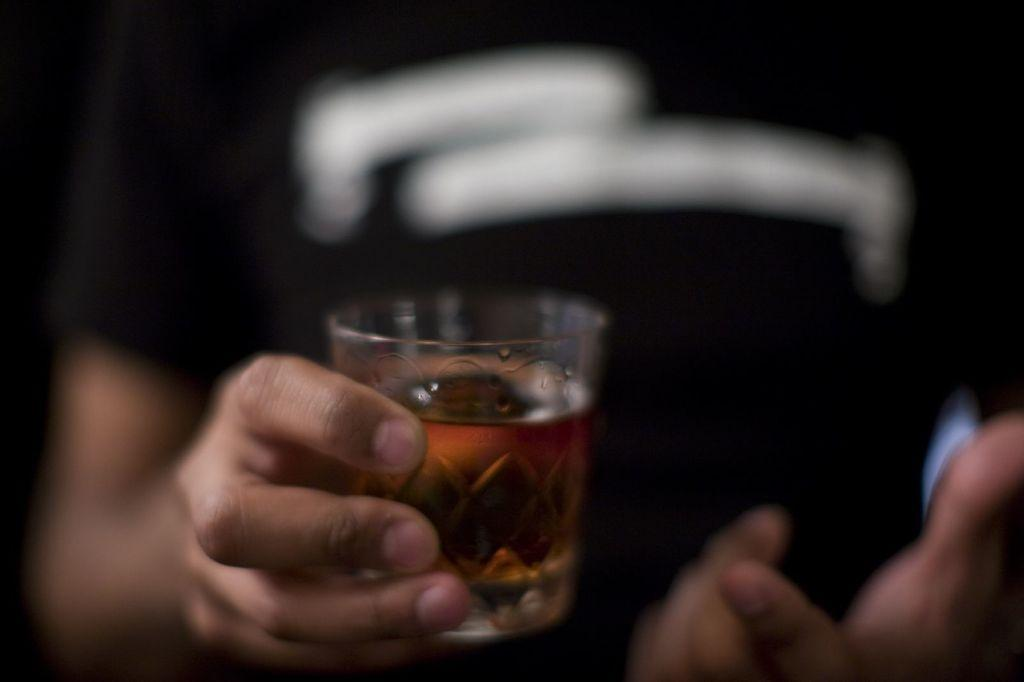Who or what is present in the image? There is a person in the image. What is the person holding in the image? The person is holding a glass in the image. What is inside the glass that the person is holding? The glass contains a drink. What type of egg can be seen in the image? There is no egg present in the image. Is the person in the image being attacked by someone or something? There is no indication of an attack in the image; the person is simply holding a glass. Can you tell me where the nearest hospital is in relation to the person in the image? The image does not provide any information about the location of a hospital, so it cannot be determined from the image. 